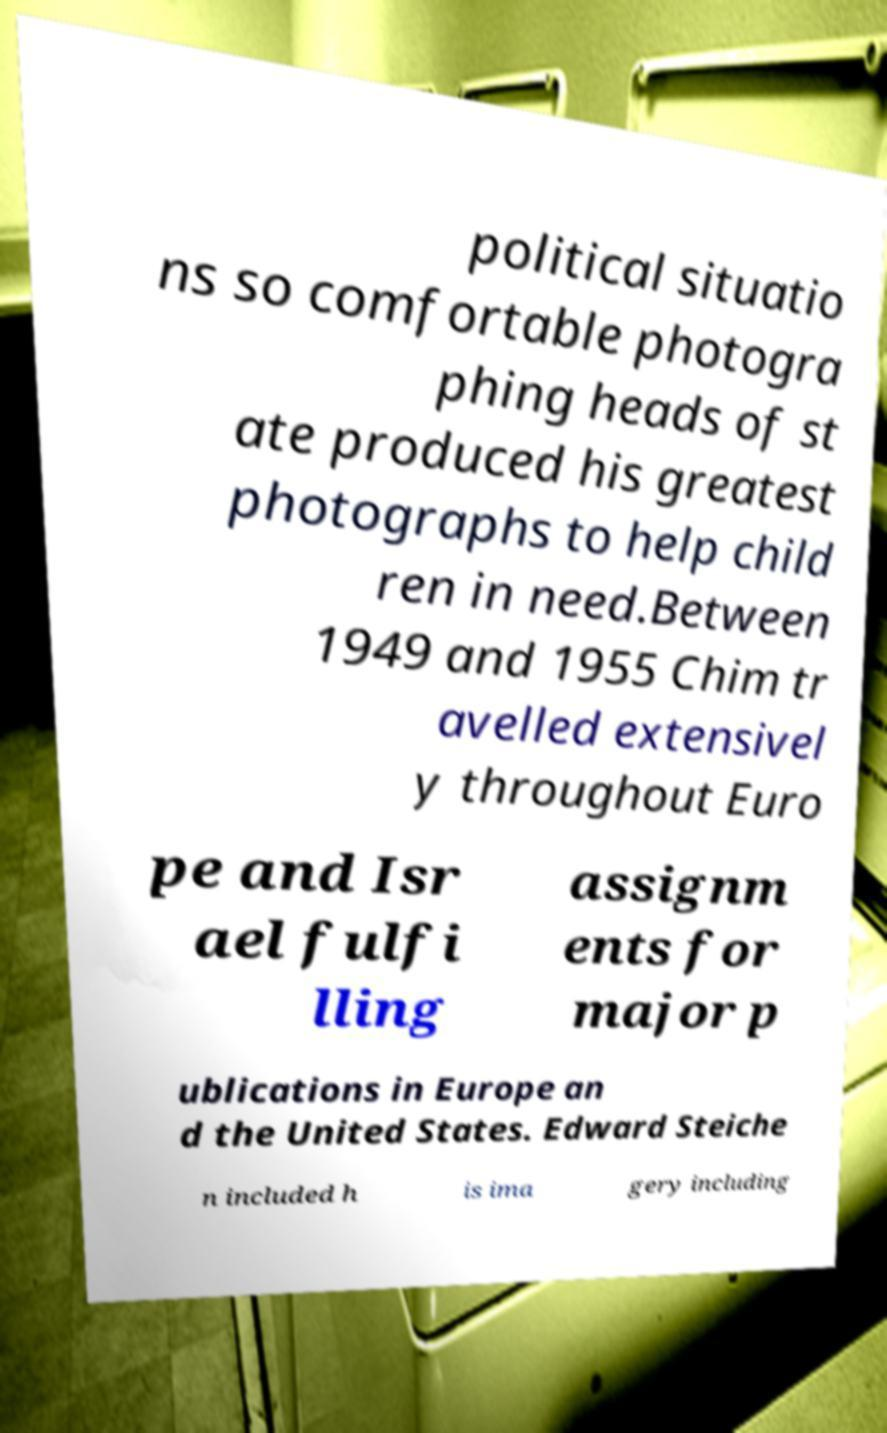Can you read and provide the text displayed in the image?This photo seems to have some interesting text. Can you extract and type it out for me? political situatio ns so comfortable photogra phing heads of st ate produced his greatest photographs to help child ren in need.Between 1949 and 1955 Chim tr avelled extensivel y throughout Euro pe and Isr ael fulfi lling assignm ents for major p ublications in Europe an d the United States. Edward Steiche n included h is ima gery including 